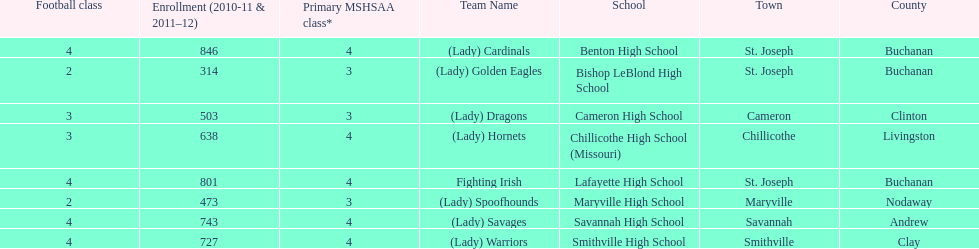Which school has the least amount of student enrollment between 2010-2011 and 2011-2012? Bishop LeBlond High School. 